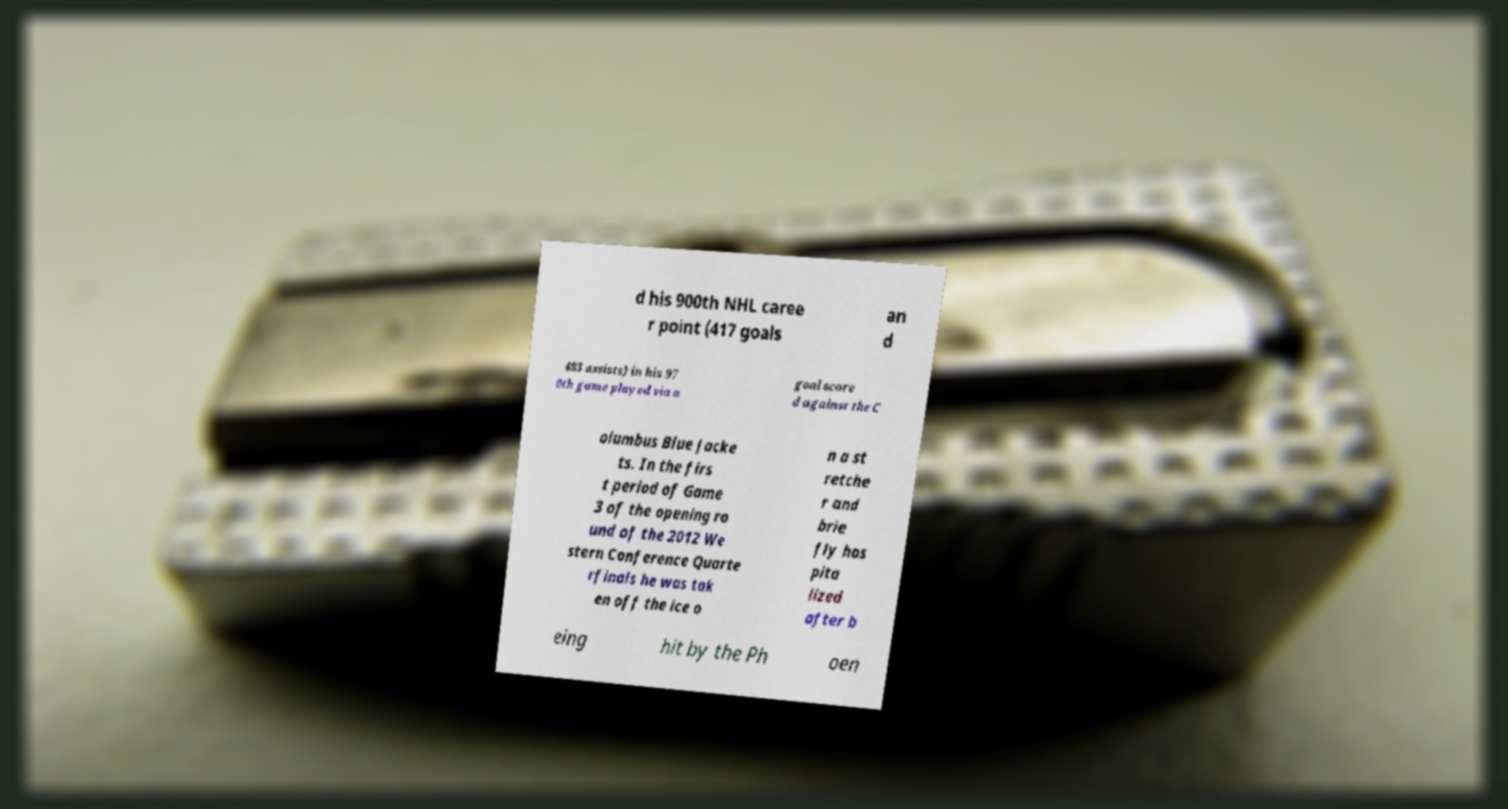Please read and relay the text visible in this image. What does it say? d his 900th NHL caree r point (417 goals an d 483 assists) in his 97 0th game played via a goal score d against the C olumbus Blue Jacke ts. In the firs t period of Game 3 of the opening ro und of the 2012 We stern Conference Quarte rfinals he was tak en off the ice o n a st retche r and brie fly hos pita lized after b eing hit by the Ph oen 